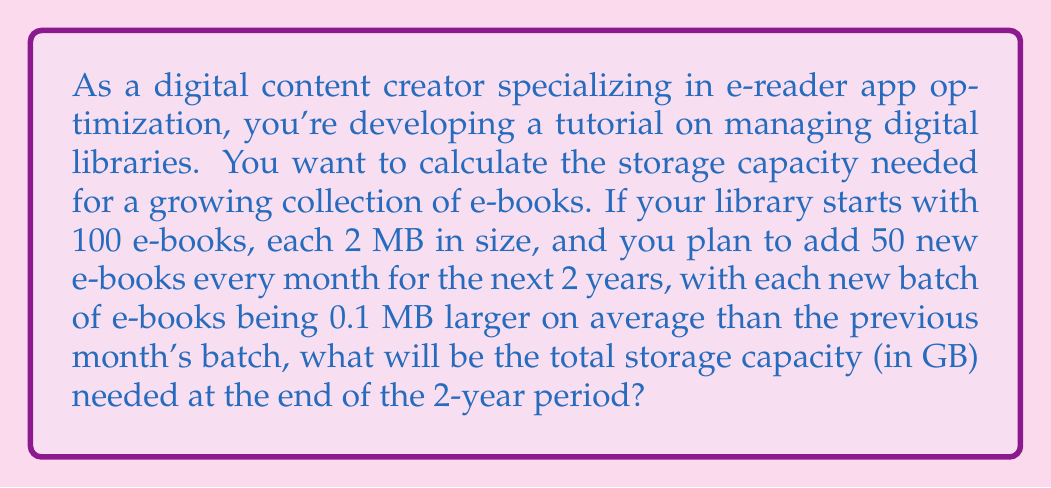Could you help me with this problem? Let's approach this step-by-step using an arithmetic sequence:

1) Initial number of e-books: 100
   Initial size per e-book: 2 MB

2) Number of months in 2 years: 24

3) Number of e-books added each month: 50

4) Size increase per month: 0.1 MB

5) Let's set up an arithmetic sequence for the size of e-books added each month:
   $a_1 = 2$ MB (first month's new e-books)
   $d = 0.1$ MB (common difference)
   $n = 24$ (number of terms/months)

6) The size of e-books added in the last month (24th term) will be:
   $a_n = a_1 + (n-1)d = 2 + (24-1)0.1 = 4.3$ MB

7) Sum of sizes for all new e-books:
   $S_n = \frac{n}{2}(a_1 + a_n) = \frac{24}{2}(2 + 4.3) = 75.6$ MB per e-book

8) Total size of new e-books:
   $75.6 \times 50 = 3780$ MB

9) Size of initial e-books:
   $100 \times 2 = 200$ MB

10) Total number of e-books after 2 years:
    $100 + (50 \times 24) = 1300$ e-books

11) Total size:
    $200 + 3780 = 3980$ MB

12) Convert to GB:
    $3980 \div 1024 \approx 3.89$ GB
Answer: The total storage capacity needed at the end of the 2-year period is approximately 3.89 GB. 